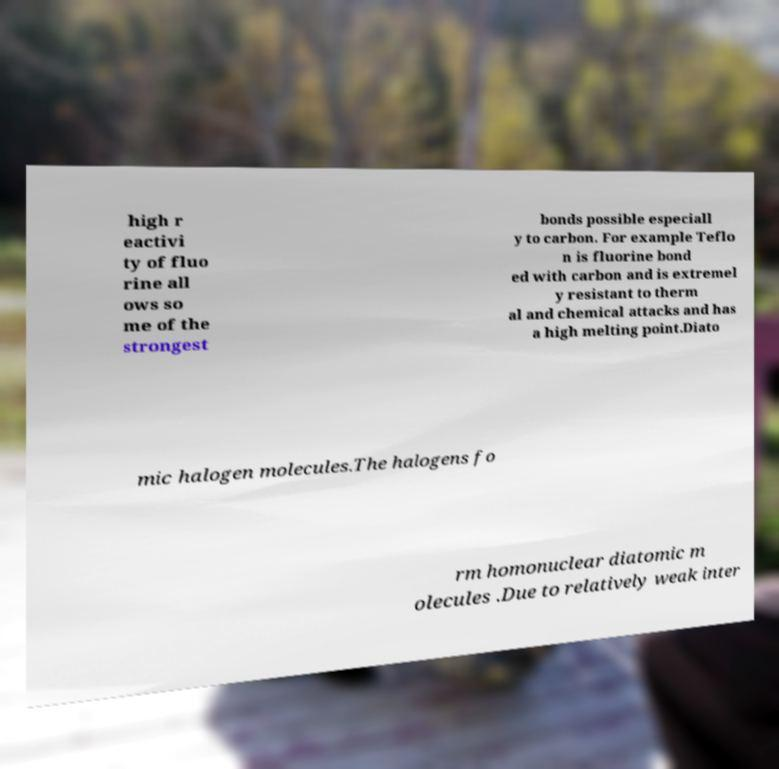Please identify and transcribe the text found in this image. high r eactivi ty of fluo rine all ows so me of the strongest bonds possible especiall y to carbon. For example Teflo n is fluorine bond ed with carbon and is extremel y resistant to therm al and chemical attacks and has a high melting point.Diato mic halogen molecules.The halogens fo rm homonuclear diatomic m olecules .Due to relatively weak inter 